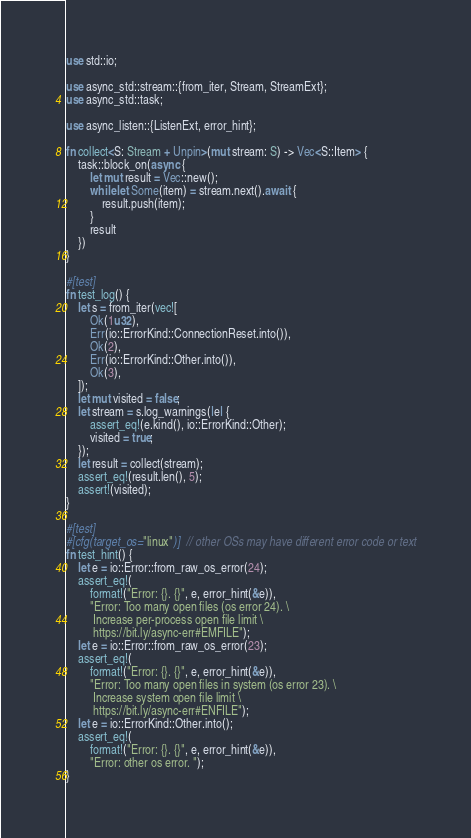Convert code to text. <code><loc_0><loc_0><loc_500><loc_500><_Rust_>use std::io;

use async_std::stream::{from_iter, Stream, StreamExt};
use async_std::task;

use async_listen::{ListenExt, error_hint};

fn collect<S: Stream + Unpin>(mut stream: S) -> Vec<S::Item> {
    task::block_on(async {
        let mut result = Vec::new();
        while let Some(item) = stream.next().await {
            result.push(item);
        }
        result
    })
}

#[test]
fn test_log() {
    let s = from_iter(vec![
        Ok(1u32),
        Err(io::ErrorKind::ConnectionReset.into()),
        Ok(2),
        Err(io::ErrorKind::Other.into()),
        Ok(3),
    ]);
    let mut visited = false;
    let stream = s.log_warnings(|e| {
        assert_eq!(e.kind(), io::ErrorKind::Other);
        visited = true;
    });
    let result = collect(stream);
    assert_eq!(result.len(), 5);
    assert!(visited);
}

#[test]
#[cfg(target_os="linux")]  // other OSs may have different error code or text
fn test_hint() {
    let e = io::Error::from_raw_os_error(24);
    assert_eq!(
        format!("Error: {}. {}", e, error_hint(&e)),
        "Error: Too many open files (os error 24). \
         Increase per-process open file limit \
         https://bit.ly/async-err#EMFILE");
    let e = io::Error::from_raw_os_error(23);
    assert_eq!(
        format!("Error: {}. {}", e, error_hint(&e)),
        "Error: Too many open files in system (os error 23). \
         Increase system open file limit \
         https://bit.ly/async-err#ENFILE");
    let e = io::ErrorKind::Other.into();
    assert_eq!(
        format!("Error: {}. {}", e, error_hint(&e)),
        "Error: other os error. ");
}
</code> 